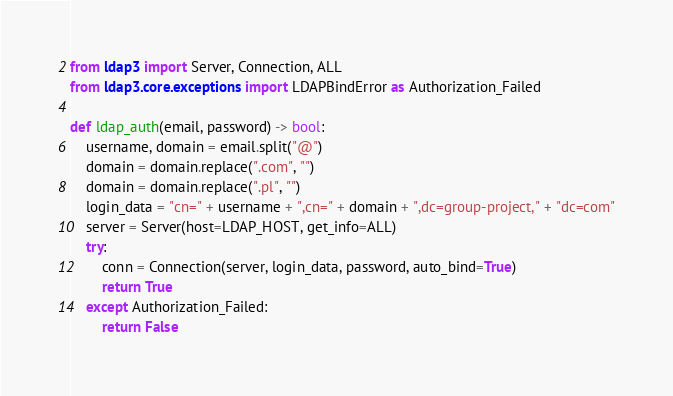<code> <loc_0><loc_0><loc_500><loc_500><_Python_>from ldap3 import Server, Connection, ALL
from ldap3.core.exceptions import LDAPBindError as Authorization_Failed

def ldap_auth(email, password) -> bool:
    username, domain = email.split("@")
    domain = domain.replace(".com", "")
    domain = domain.replace(".pl", "")
    login_data = "cn=" + username + ",cn=" + domain + ",dc=group-project," + "dc=com"
    server = Server(host=LDAP_HOST, get_info=ALL)
    try:
        conn = Connection(server, login_data, password, auto_bind=True)
        return True
    except Authorization_Failed:
        return False
</code> 